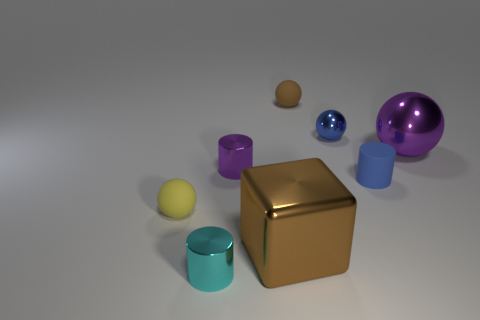Add 2 small purple cylinders. How many objects exist? 10 Subtract all cylinders. How many objects are left? 5 Subtract all large balls. Subtract all purple balls. How many objects are left? 6 Add 4 cyan things. How many cyan things are left? 5 Add 6 small purple things. How many small purple things exist? 7 Subtract 1 brown balls. How many objects are left? 7 